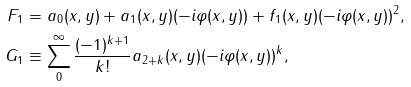<formula> <loc_0><loc_0><loc_500><loc_500>F _ { 1 } & = a _ { 0 } ( x , y ) + a _ { 1 } ( x , y ) ( - i \varphi ( x , y ) ) + f _ { 1 } ( x , y ) ( - i \varphi ( x , y ) ) ^ { 2 } , \\ G _ { 1 } & \equiv \sum ^ { \infty } _ { 0 } \frac { ( - 1 ) ^ { k + 1 } } { k ! } a _ { 2 + k } ( x , y ) ( - i \varphi ( x , y ) ) ^ { k } ,</formula> 